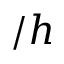<formula> <loc_0><loc_0><loc_500><loc_500>/ h</formula> 